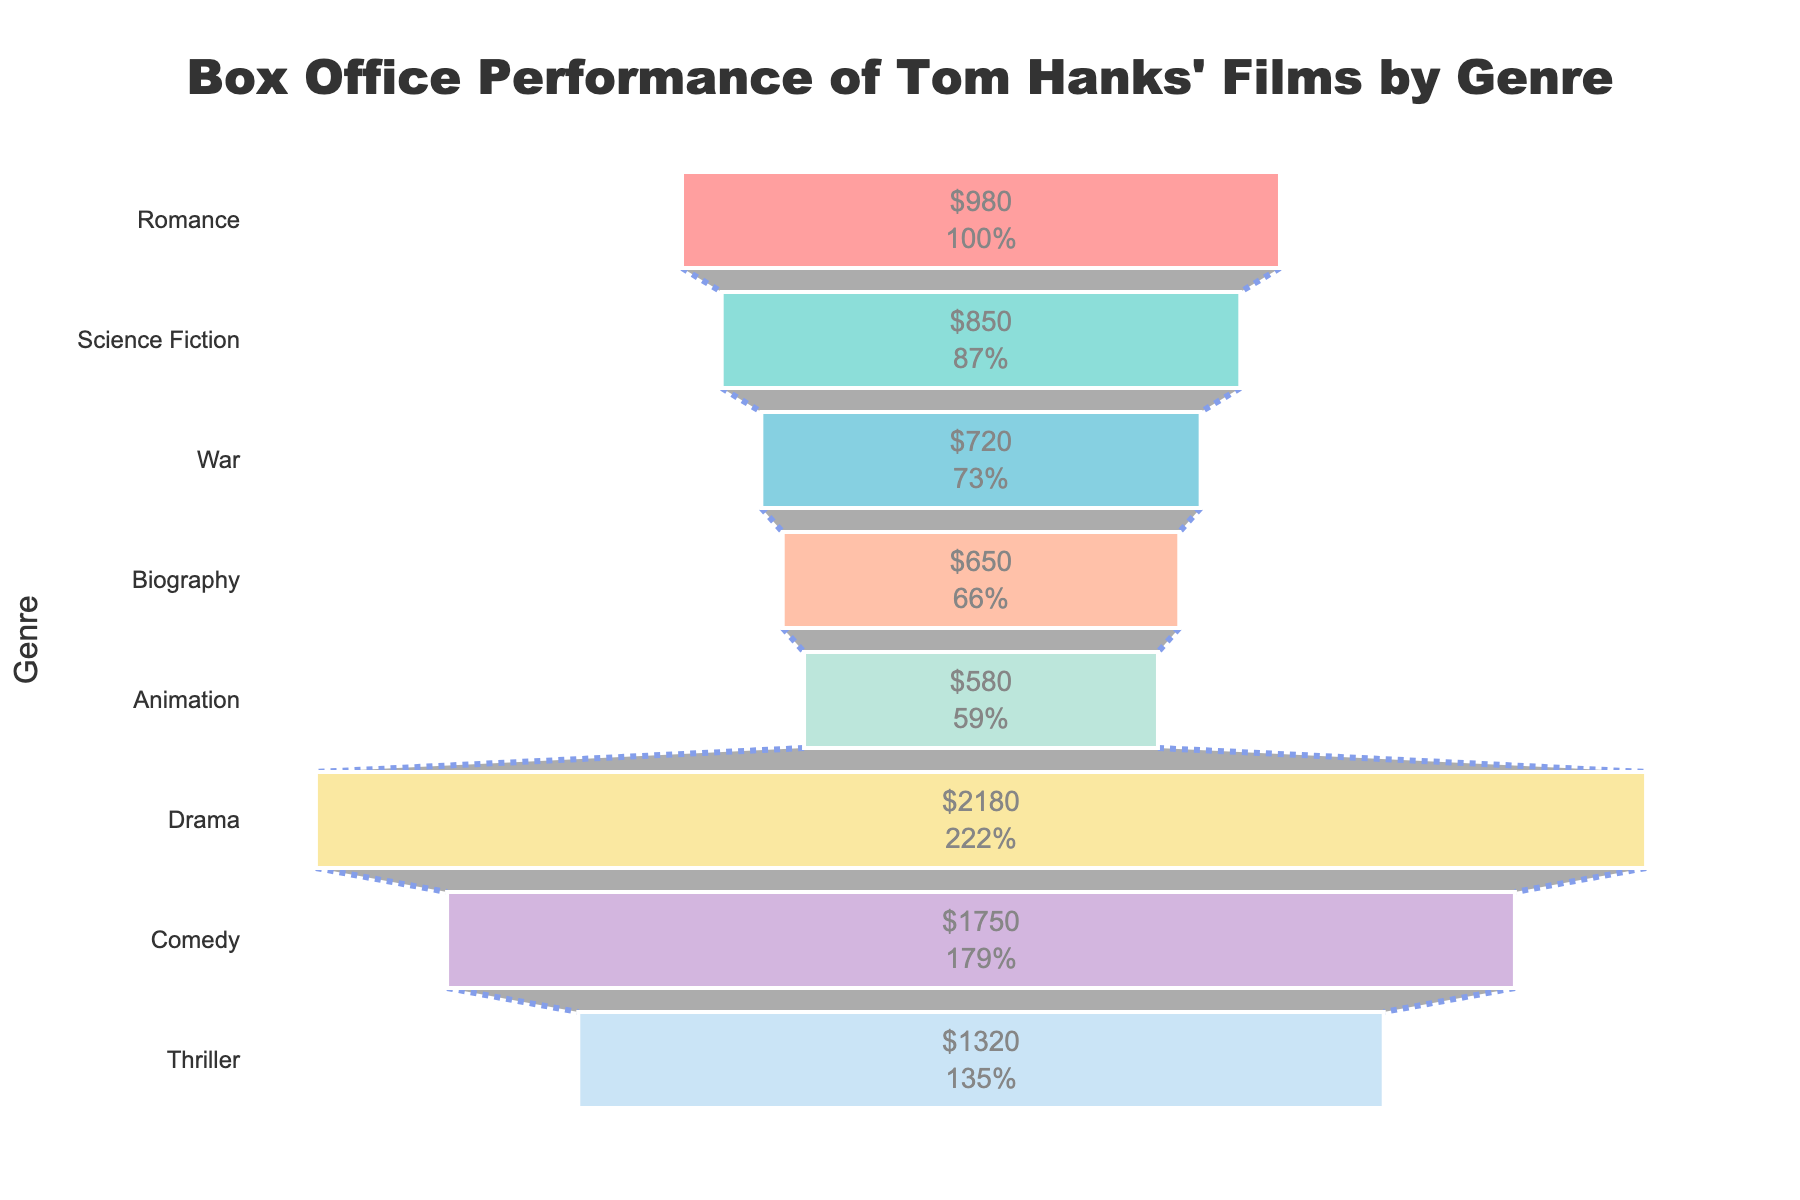What is the title of the chart? The title is located at the top center of the chart, written in a large font. It clearly indicates the overall topic of the data.
Answer: Box Office Performance of Tom Hanks' Films by Genre How many genres are represented in the chart? By counting the different segments in the funnel chart, we can determine the number of genres represented.
Answer: 8 Which genre has the highest box office gross, and how much is it? Observing the funnel chart from the top, we see which genre occupies the largest segment and locate the box office gross value associated with it.
Answer: Drama, $2180 million Which genre has the least box office gross, and what is the value? Looking at the bottom of the funnel chart, we can identify the genre with the smallest segment and find its corresponding box office gross.
Answer: Animation, $580 million What is the total box office gross of all the genres combined? Summing up all the values of the segments in the funnel chart gives us the total box office gross.
Answer: $8020 million What is the difference in box office gross between the highest and lowest-grossing genres? We subtract the box office gross value of the lowest-grossing genre from that of the highest-grossing genre.
Answer: $1600 million How much do Comedy and Thriller genres collectively gross at the box office? Adding the box office gross values of the Comedy and Thriller genres provides the collective gross.
Answer: $3070 million Which genres have a box office gross less than $1000 million? By identifying segments with values less than $1000 million, we find the genres that meet the criteria.
Answer: Romance, Science Fiction, War, Biography, Animation What percentage of the total box office gross does the Science Fiction genre represent? Dividing the Science Fiction genre's box office gross by the total gross and multiplying by 100 gives the percentage.
Answer: 10.6% What is the average box office gross per genre? Dividing the total box office gross by the number of genres provides the average gross per genre.
Answer: $1002.5 million 